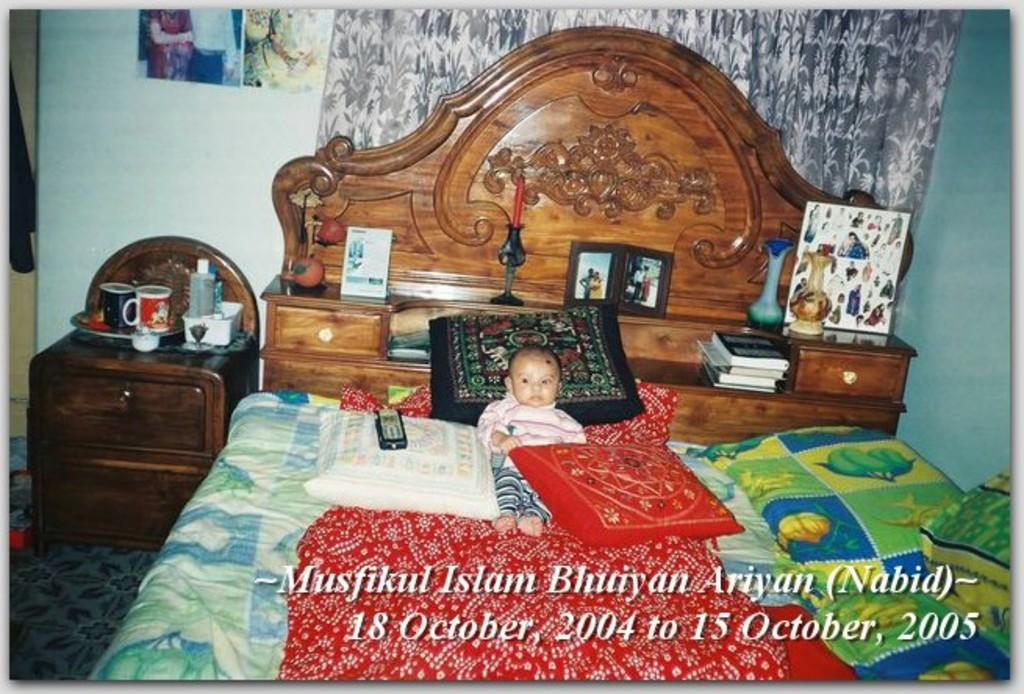What is the main subject of the image? There is a baby sleeping on the bed. What is located near the bed? There is a table beside the bed. What can be seen in the background of the image? There is a wall in the background. What grade does the baby receive for their performance in the image? There is no grade given in the image, as it is a photograph of a baby sleeping and not an evaluation of any kind. 